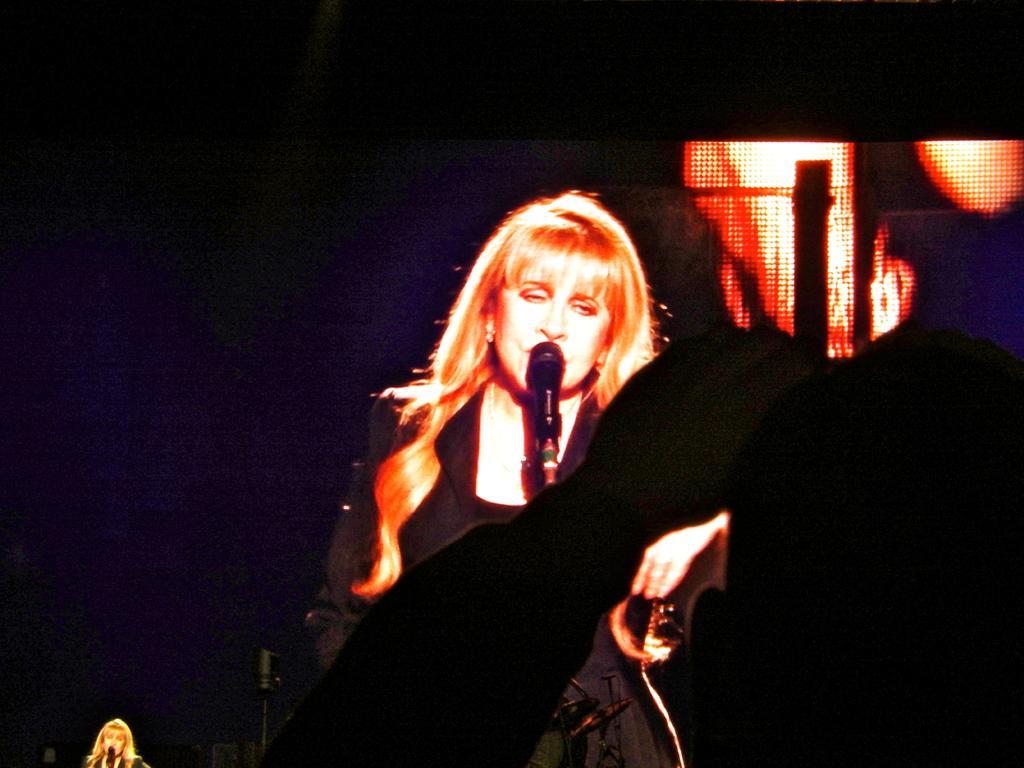Can you describe this image briefly? Background portion of the picture is completely dark and we can see a woman and mike at the bottom left corner. Here we can see a woman in a black dress. This is a mike. 